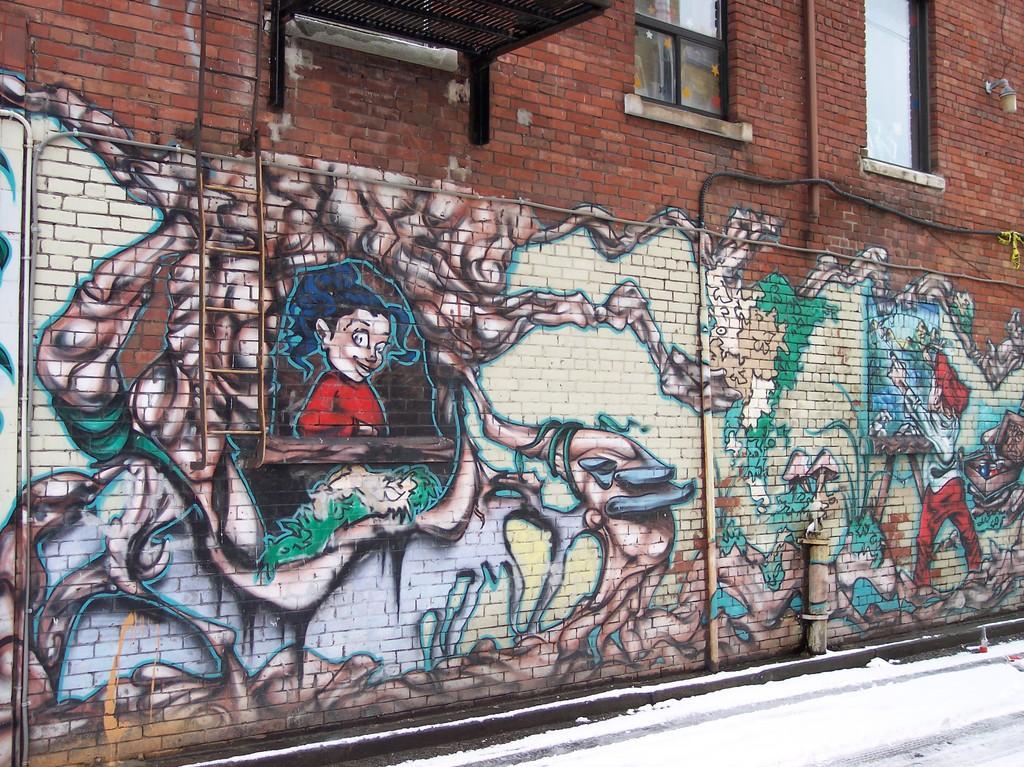Please provide a concise description of this image. In the center of the image there is a wall and we can see graffiti on it and there are windows. 